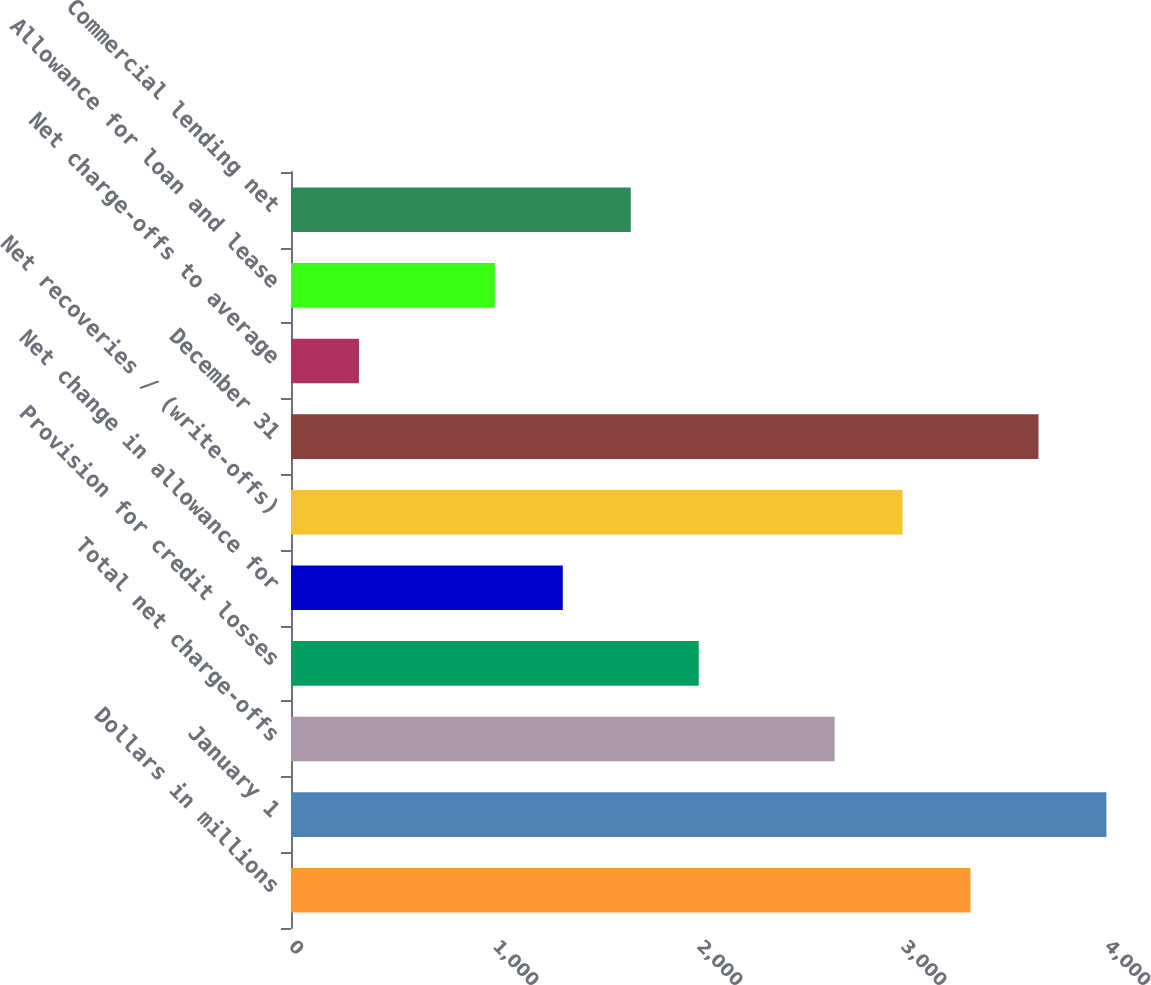Convert chart to OTSL. <chart><loc_0><loc_0><loc_500><loc_500><bar_chart><fcel>Dollars in millions<fcel>January 1<fcel>Total net charge-offs<fcel>Provision for credit losses<fcel>Net change in allowance for<fcel>Net recoveries / (write-offs)<fcel>December 31<fcel>Net charge-offs to average<fcel>Allowance for loan and lease<fcel>Commercial lending net<nl><fcel>3331.01<fcel>3997.21<fcel>2664.81<fcel>1998.61<fcel>1332.41<fcel>2997.91<fcel>3664.11<fcel>333.11<fcel>999.31<fcel>1665.51<nl></chart> 